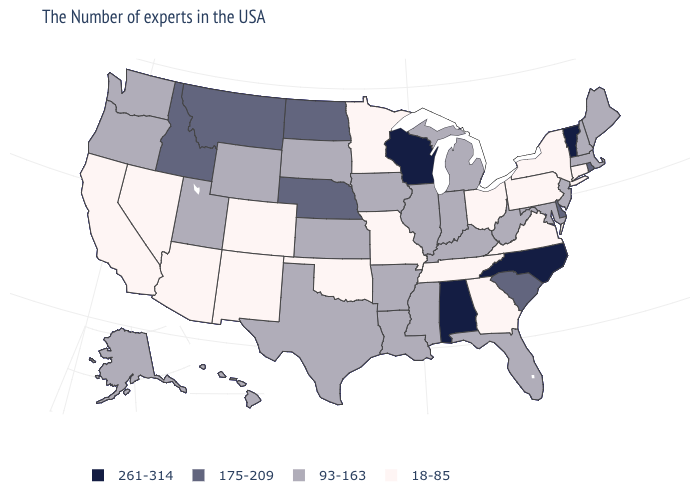What is the lowest value in states that border Connecticut?
Quick response, please. 18-85. Name the states that have a value in the range 261-314?
Be succinct. Vermont, North Carolina, Alabama, Wisconsin. How many symbols are there in the legend?
Give a very brief answer. 4. Among the states that border Washington , does Oregon have the highest value?
Be succinct. No. What is the value of Iowa?
Short answer required. 93-163. Does Montana have the same value as Nebraska?
Answer briefly. Yes. Among the states that border Texas , which have the lowest value?
Concise answer only. Oklahoma, New Mexico. Does Delaware have the highest value in the USA?
Answer briefly. No. Does Delaware have the same value as Nevada?
Keep it brief. No. Name the states that have a value in the range 175-209?
Keep it brief. Rhode Island, Delaware, South Carolina, Nebraska, North Dakota, Montana, Idaho. Name the states that have a value in the range 93-163?
Answer briefly. Maine, Massachusetts, New Hampshire, New Jersey, Maryland, West Virginia, Florida, Michigan, Kentucky, Indiana, Illinois, Mississippi, Louisiana, Arkansas, Iowa, Kansas, Texas, South Dakota, Wyoming, Utah, Washington, Oregon, Alaska, Hawaii. What is the lowest value in states that border Nebraska?
Keep it brief. 18-85. What is the lowest value in the USA?
Concise answer only. 18-85. Does Vermont have the highest value in the Northeast?
Be succinct. Yes. Does Rhode Island have a higher value than Utah?
Short answer required. Yes. 